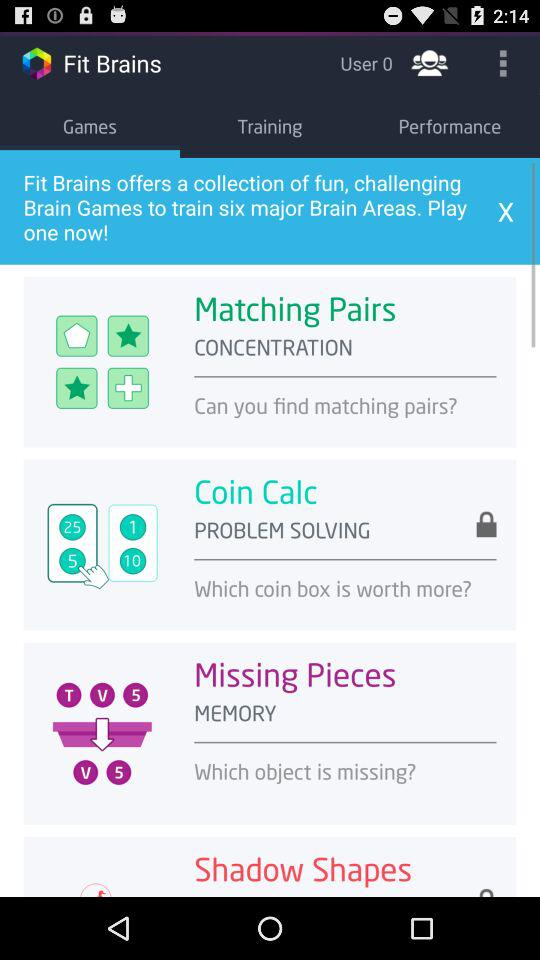Which tab is selected? The selected tab is "Games". 